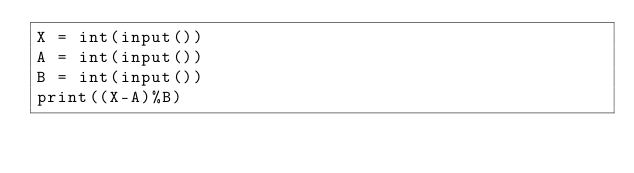<code> <loc_0><loc_0><loc_500><loc_500><_Python_>X = int(input())
A = int(input())
B = int(input())
print((X-A)%B)</code> 